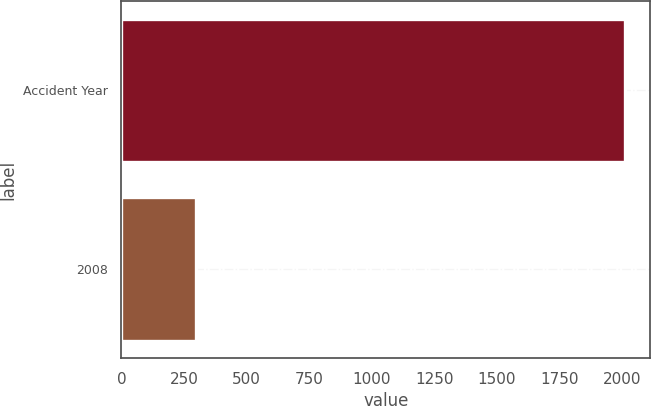Convert chart. <chart><loc_0><loc_0><loc_500><loc_500><bar_chart><fcel>Accident Year<fcel>2008<nl><fcel>2013<fcel>300<nl></chart> 